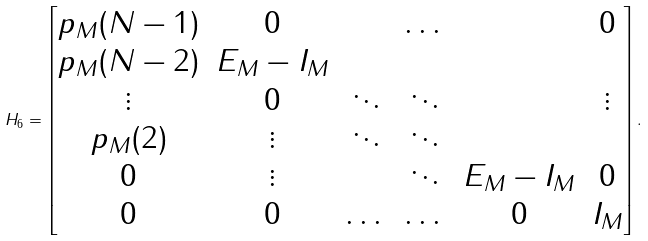<formula> <loc_0><loc_0><loc_500><loc_500>H _ { 6 } = \begin{bmatrix} p _ { M } ( N - 1 ) & 0 & & \dots & & 0 \\ p _ { M } ( N - 2 ) & E _ { M } - I _ { M } & & & & \\ \vdots & 0 & \ddots & \ddots & & \vdots \\ p _ { M } ( 2 ) & \vdots & \ddots & \ddots & & \\ 0 & \vdots & & \ddots & E _ { M } - I _ { M } & 0 \\ 0 & 0 & \dots & \dots & 0 & I _ { M } \end{bmatrix} .</formula> 